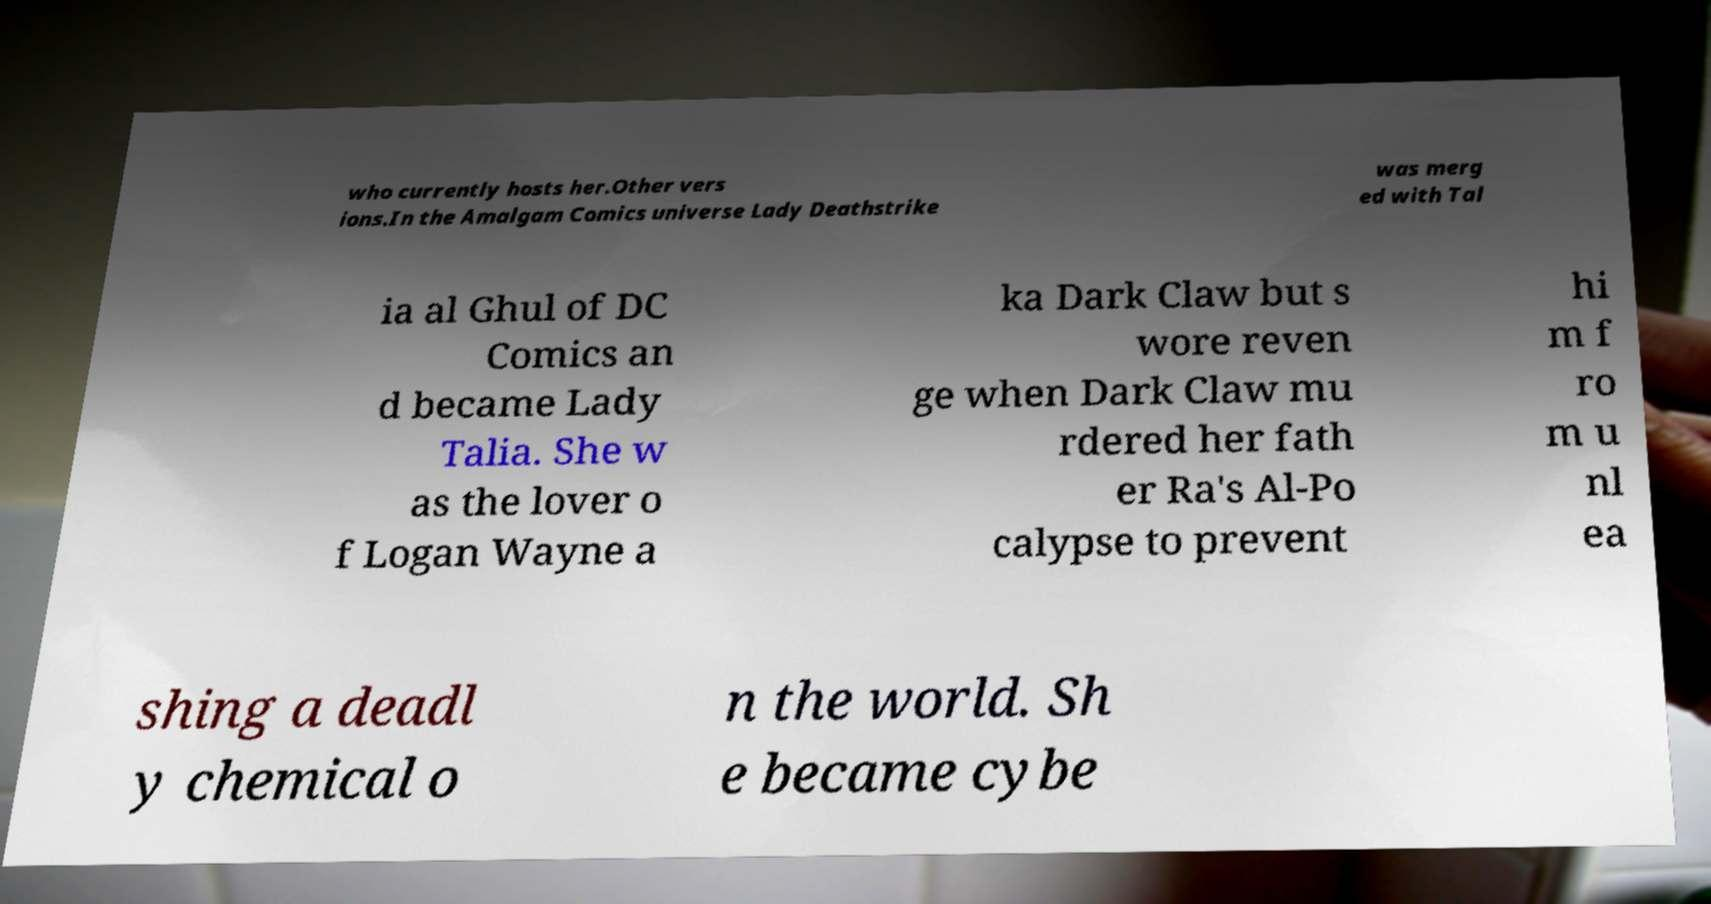There's text embedded in this image that I need extracted. Can you transcribe it verbatim? who currently hosts her.Other vers ions.In the Amalgam Comics universe Lady Deathstrike was merg ed with Tal ia al Ghul of DC Comics an d became Lady Talia. She w as the lover o f Logan Wayne a ka Dark Claw but s wore reven ge when Dark Claw mu rdered her fath er Ra's Al-Po calypse to prevent hi m f ro m u nl ea shing a deadl y chemical o n the world. Sh e became cybe 